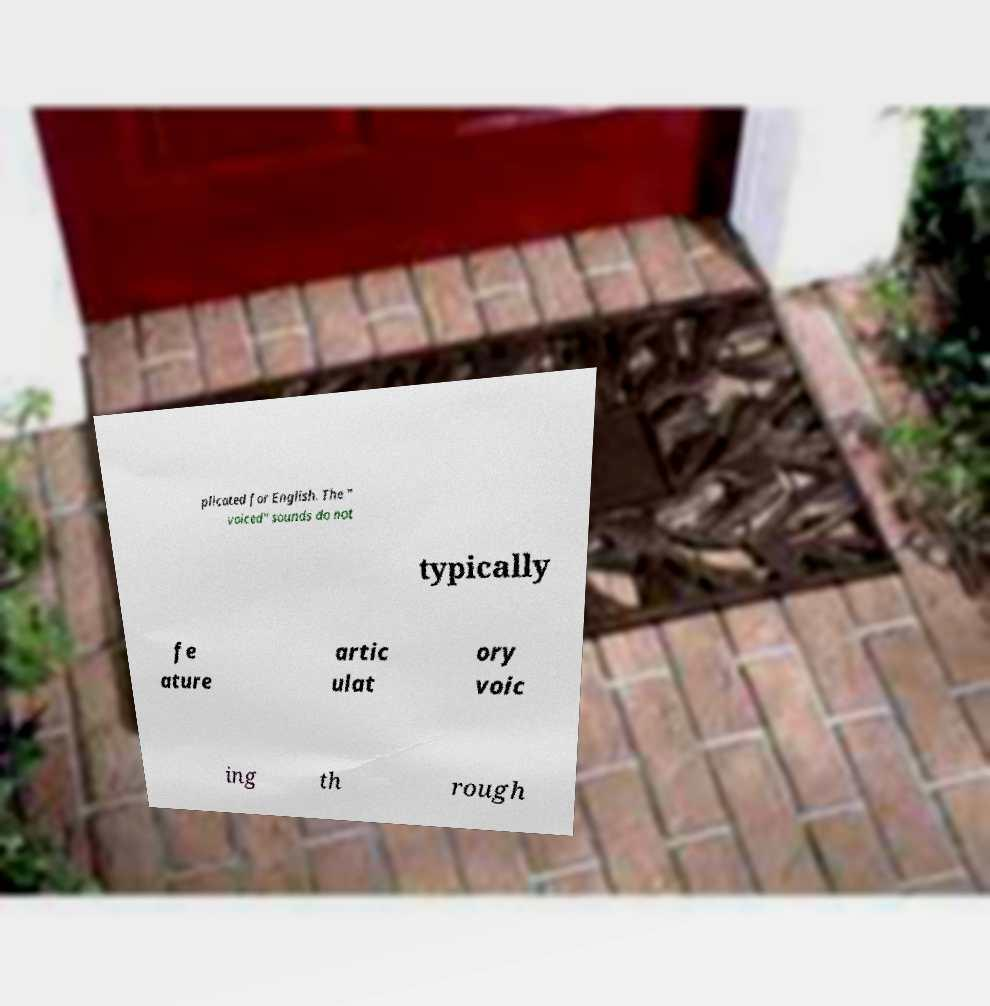Please identify and transcribe the text found in this image. plicated for English. The " voiced" sounds do not typically fe ature artic ulat ory voic ing th rough 